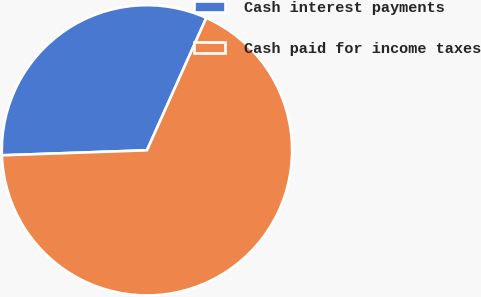Convert chart to OTSL. <chart><loc_0><loc_0><loc_500><loc_500><pie_chart><fcel>Cash interest payments<fcel>Cash paid for income taxes<nl><fcel>32.26%<fcel>67.74%<nl></chart> 